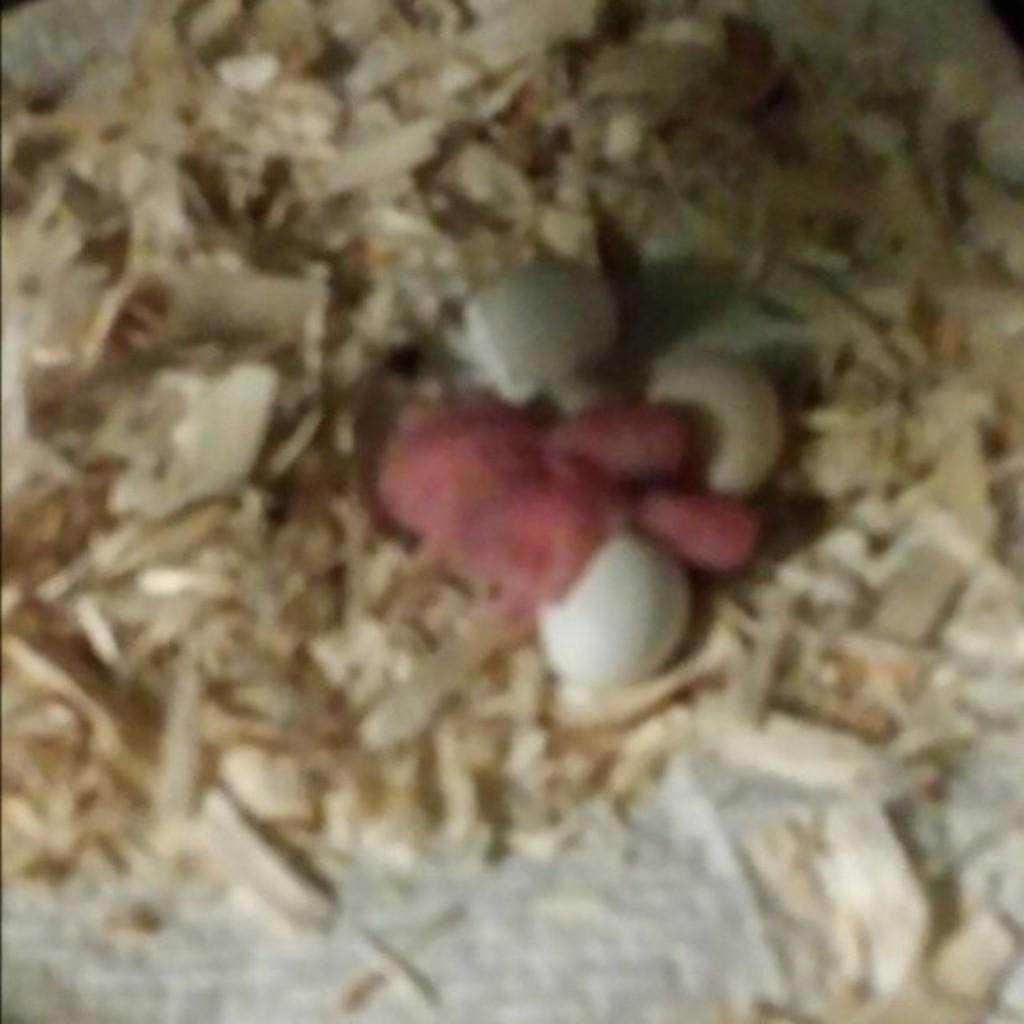In one or two sentences, can you explain what this image depicts? In this blur image, we can see some wood waste. 